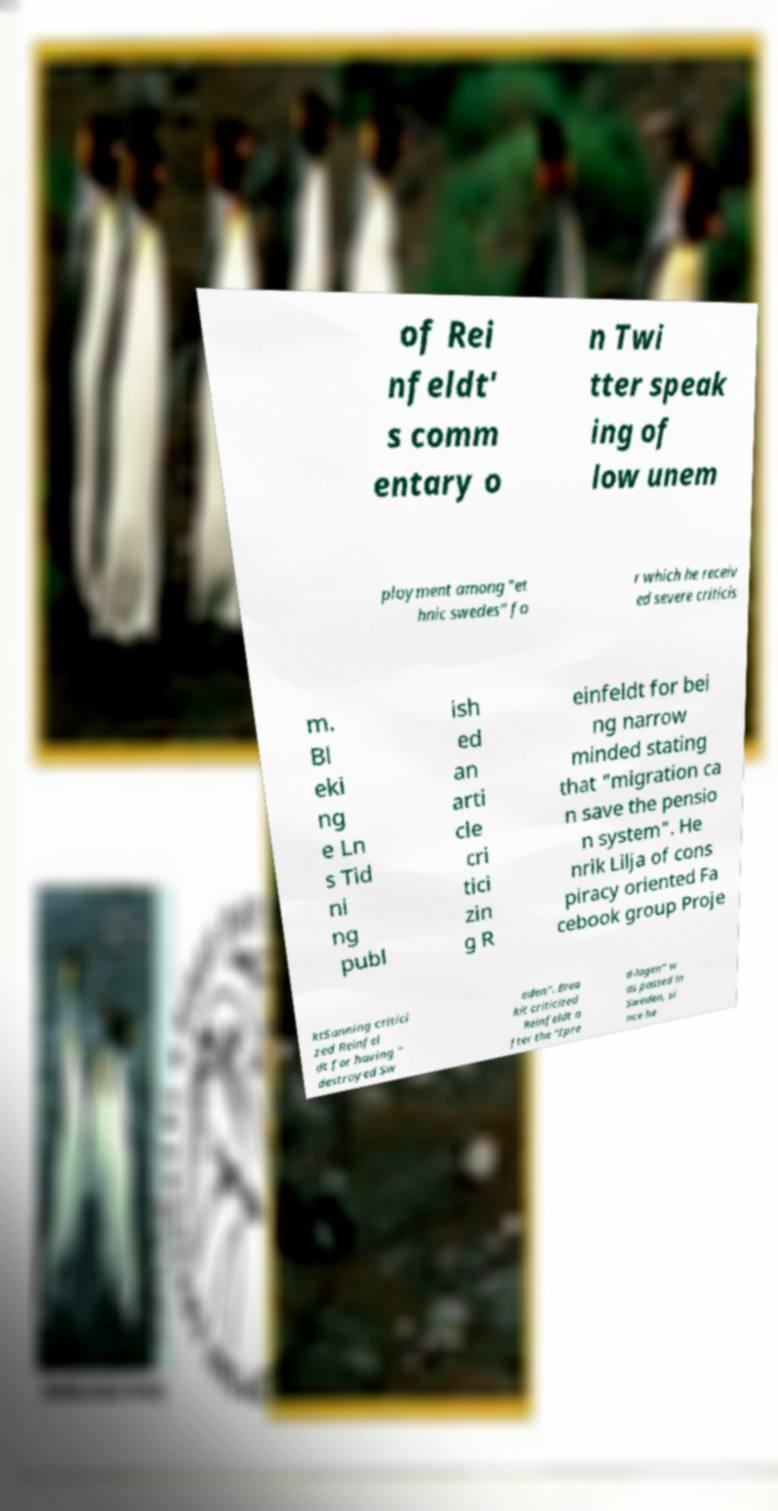Please read and relay the text visible in this image. What does it say? of Rei nfeldt' s comm entary o n Twi tter speak ing of low unem ployment among "et hnic swedes" fo r which he receiv ed severe criticis m. Bl eki ng e Ln s Tid ni ng publ ish ed an arti cle cri tici zin g R einfeldt for bei ng narrow minded stating that "migration ca n save the pensio n system". He nrik Lilja of cons piracy oriented Fa cebook group Proje ktSanning critici zed Reinfel dt for having " destroyed Sw eden". Brea kit criticized Reinfeldt a fter the "Ipre d-lagen" w as passed in Sweden, si nce he 